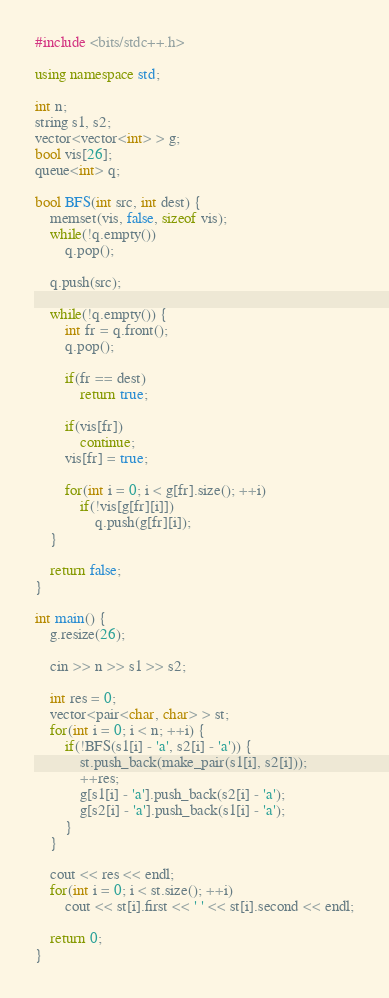Convert code to text. <code><loc_0><loc_0><loc_500><loc_500><_C++_>#include <bits/stdc++.h>

using namespace std;

int n;
string s1, s2;
vector<vector<int> > g;
bool vis[26];
queue<int> q;

bool BFS(int src, int dest) {
	memset(vis, false, sizeof vis);
	while(!q.empty())
		q.pop();

	q.push(src);

	while(!q.empty()) {
		int fr = q.front();
		q.pop();

		if(fr == dest)
			return true;

		if(vis[fr])
			continue;
		vis[fr] = true;

		for(int i = 0; i < g[fr].size(); ++i)
			if(!vis[g[fr][i]])
				q.push(g[fr][i]);
	}

	return false;
}

int main() {
	g.resize(26);

	cin >> n >> s1 >> s2;

	int res = 0;
	vector<pair<char, char> > st;
	for(int i = 0; i < n; ++i) {
		if(!BFS(s1[i] - 'a', s2[i] - 'a')) {
			st.push_back(make_pair(s1[i], s2[i]));
			++res;
			g[s1[i] - 'a'].push_back(s2[i] - 'a');
			g[s2[i] - 'a'].push_back(s1[i] - 'a');
		}
	}

	cout << res << endl;
	for(int i = 0; i < st.size(); ++i)
		cout << st[i].first << ' ' << st[i].second << endl;

	return 0;
}

</code> 